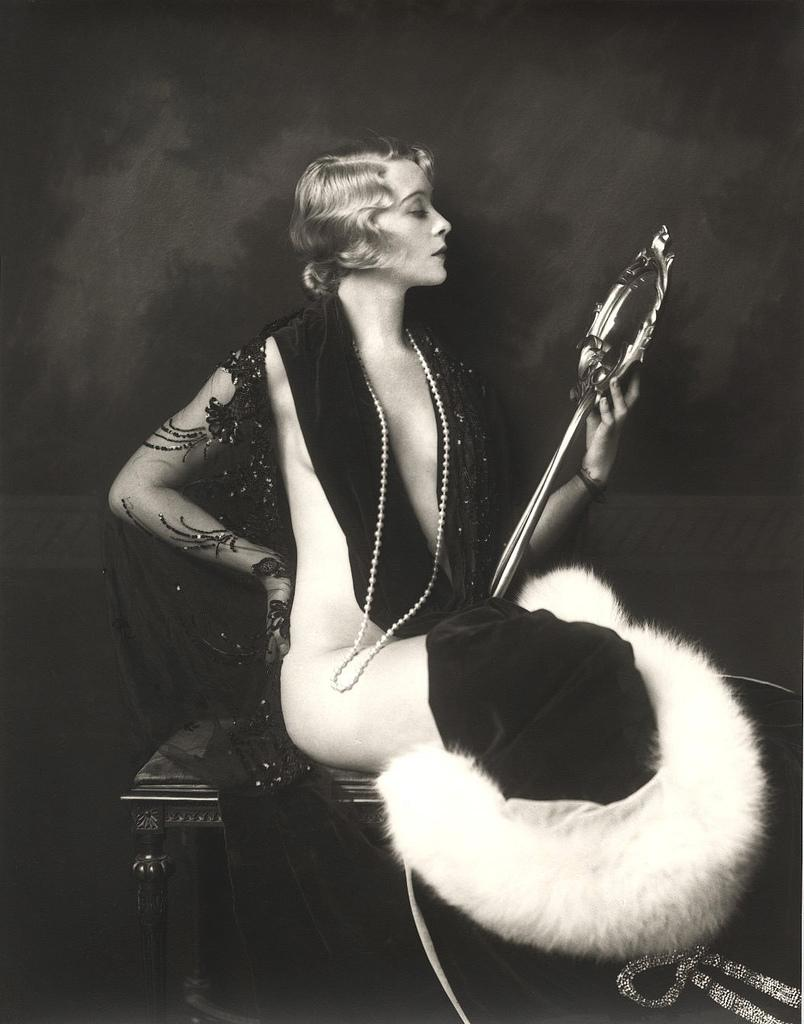Who is the main subject in the image? There is a woman in the image. What is the woman wearing? The woman is wearing a black dress. What is the woman doing with her hand in the image? The woman is holding an object with one hand. What is the woman sitting on in the image? The woman is sitting on a stool. What is the color of the background in the image? The background of the image is dark in color. What type of brake can be seen in the image? There is no brake present in the image. How many cherries is the woman holding in the image? There are no cherries visible in the image. What type of throne is the woman sitting on in the image? The woman is sitting on a stool, not a throne, in the image. 